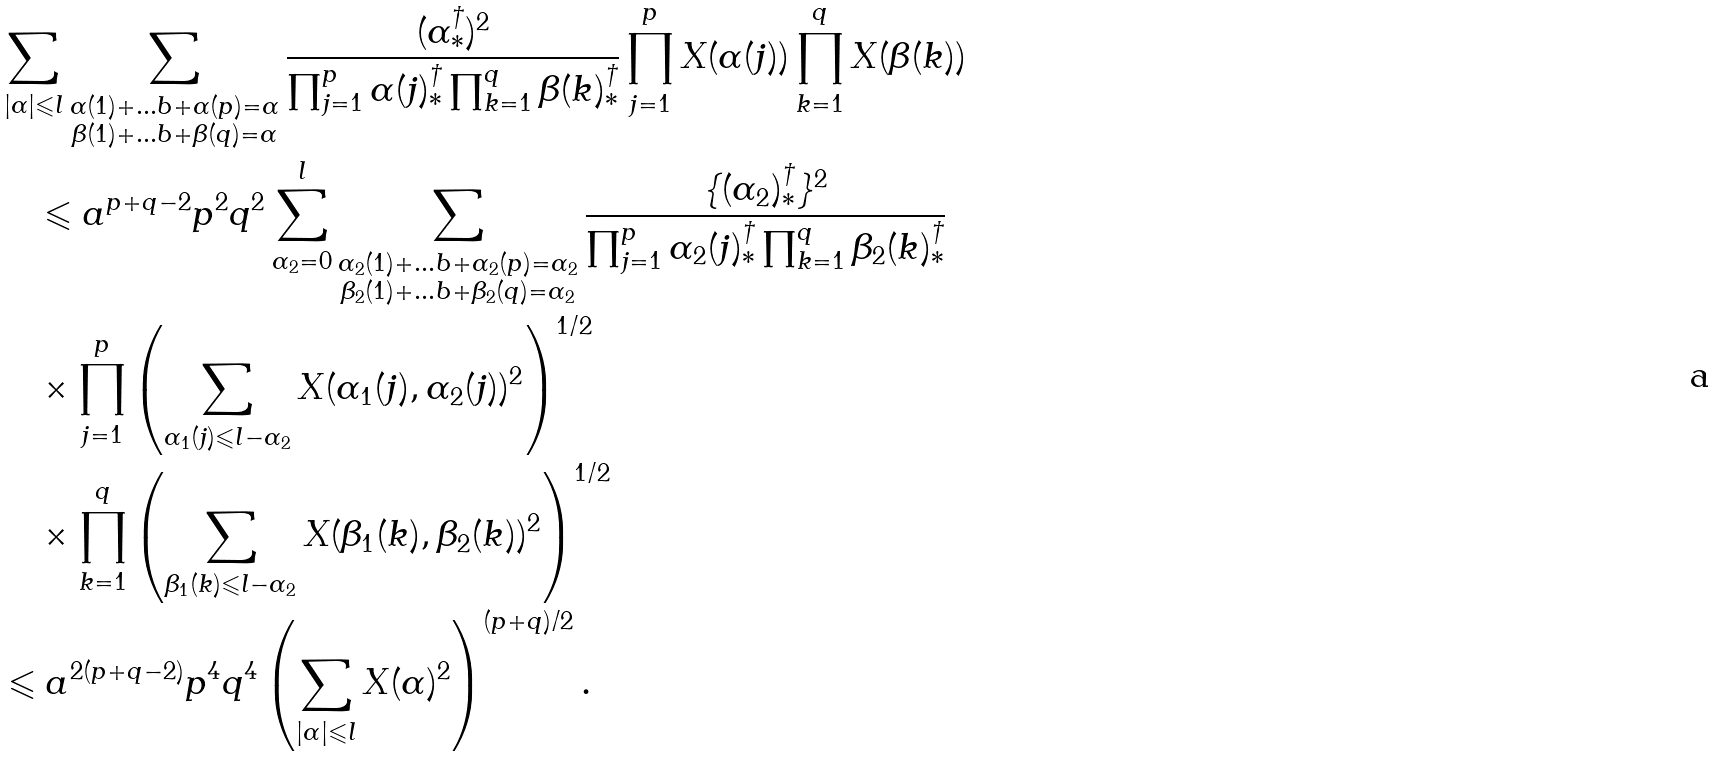<formula> <loc_0><loc_0><loc_500><loc_500>& \sum _ { | \alpha | \leqslant { l } } \sum _ { \substack { \alpha ( 1 ) + \dots b + \alpha ( p ) = \alpha \\ \beta ( 1 ) + \dots b + \beta ( q ) = \alpha } } \frac { ( \alpha _ { \ast } ^ { \dagger } ) ^ { 2 } } { \prod _ { j = 1 } ^ { p } \alpha ( j ) _ { \ast } ^ { \dagger } \prod _ { k = 1 } ^ { q } \beta ( k ) _ { \ast } ^ { \dagger } } \prod _ { j = 1 } ^ { p } X ( \alpha ( j ) ) \prod _ { k = 1 } ^ { q } X ( \beta ( k ) ) \\ & \quad \leqslant a ^ { p + q - 2 } p ^ { 2 } q ^ { 2 } \sum _ { \alpha _ { 2 } = 0 } ^ { l } \sum _ { \substack { \alpha _ { 2 } ( 1 ) + \dots b + \alpha _ { 2 } ( p ) = \alpha _ { 2 } \\ \beta _ { 2 } ( 1 ) + \dots b + \beta _ { 2 } ( q ) = \alpha _ { 2 } } } \frac { \{ ( \alpha _ { 2 } ) _ { \ast } ^ { \dagger } \} ^ { 2 } } { \prod _ { j = 1 } ^ { p } \alpha _ { 2 } ( j ) _ { \ast } ^ { \dagger } \prod _ { k = 1 } ^ { q } \beta _ { 2 } ( k ) _ { \ast } ^ { \dagger } } \\ & \quad \times \prod _ { j = 1 } ^ { p } \left ( \sum _ { \alpha _ { 1 } ( j ) \leqslant { l } - \alpha _ { 2 } } X ( \alpha _ { 1 } ( j ) , \alpha _ { 2 } ( j ) ) ^ { 2 } \right ) ^ { 1 / 2 } \\ & \quad \times \prod _ { k = 1 } ^ { q } \left ( \sum _ { \beta _ { 1 } ( k ) \leqslant { l } - \alpha _ { 2 } } X ( \beta _ { 1 } ( k ) , \beta _ { 2 } ( k ) ) ^ { 2 } \right ) ^ { 1 / 2 } \\ & \leqslant a ^ { 2 ( p + q - 2 ) } p ^ { 4 } q ^ { 4 } \left ( \sum _ { | \alpha | \leqslant { l } } X ( \alpha ) ^ { 2 } \right ) ^ { ( p + q ) / 2 } .</formula> 